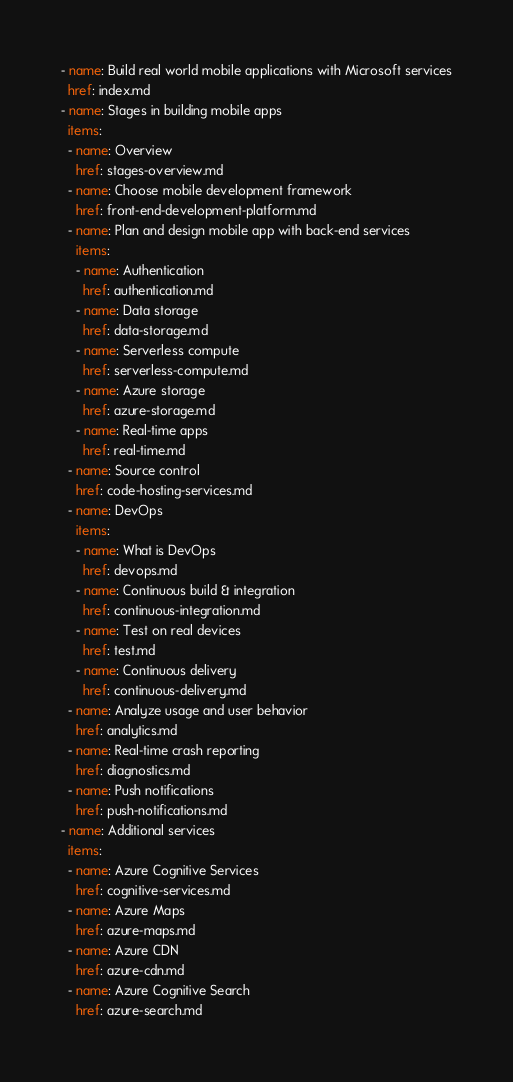<code> <loc_0><loc_0><loc_500><loc_500><_YAML_>- name: Build real world mobile applications with Microsoft services
  href: index.md
- name: Stages in building mobile apps
  items:
  - name: Overview
    href: stages-overview.md
  - name: Choose mobile development framework
    href: front-end-development-platform.md
  - name: Plan and design mobile app with back-end services
    items:
    - name: Authentication
      href: authentication.md
    - name: Data storage
      href: data-storage.md
    - name: Serverless compute
      href: serverless-compute.md
    - name: Azure storage
      href: azure-storage.md
    - name: Real-time apps
      href: real-time.md
  - name: Source control
    href: code-hosting-services.md
  - name: DevOps
    items:
    - name: What is DevOps
      href: devops.md
    - name: Continuous build & integration
      href: continuous-integration.md
    - name: Test on real devices
      href: test.md
    - name: Continuous delivery
      href: continuous-delivery.md
  - name: Analyze usage and user behavior 
    href: analytics.md
  - name: Real-time crash reporting
    href: diagnostics.md
  - name: Push notifications
    href: push-notifications.md
- name: Additional services
  items:
  - name: Azure Cognitive Services 
    href: cognitive-services.md
  - name: Azure Maps 
    href: azure-maps.md
  - name: Azure CDN
    href: azure-cdn.md      
  - name: Azure Cognitive Search
    href: azure-search.md</code> 